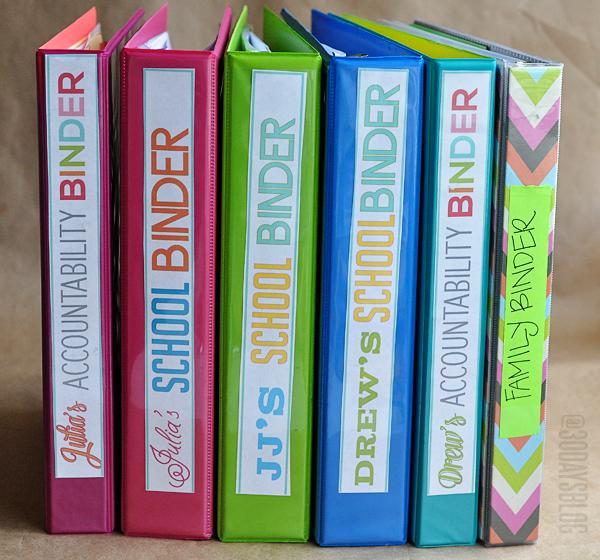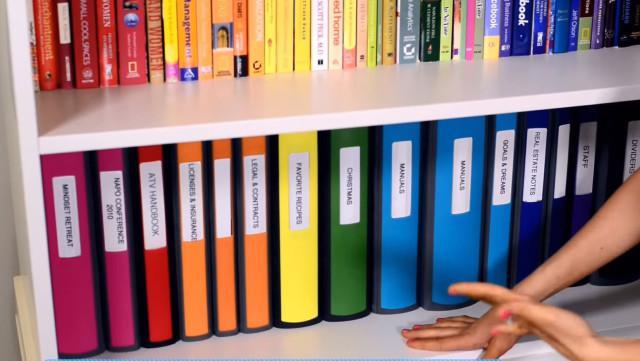The first image is the image on the left, the second image is the image on the right. Examine the images to the left and right. Is the description "There is an open binder." accurate? Answer yes or no. No. The first image is the image on the left, the second image is the image on the right. Considering the images on both sides, is "At least one binder with pages in it is opened." valid? Answer yes or no. No. 